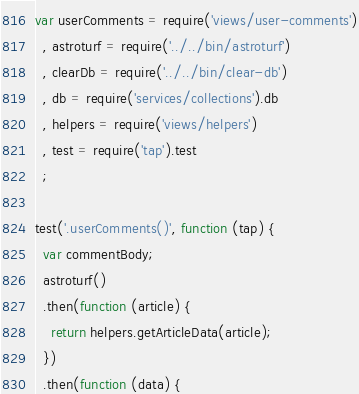Convert code to text. <code><loc_0><loc_0><loc_500><loc_500><_JavaScript_>var userComments = require('views/user-comments')
  , astroturf = require('../../bin/astroturf')
  , clearDb = require('../../bin/clear-db')
  , db = require('services/collections').db
  , helpers = require('views/helpers')
  , test = require('tap').test
  ;

test('.userComments()', function (tap) {
  var commentBody;
  astroturf()
  .then(function (article) {
    return helpers.getArticleData(article);
  })
  .then(function (data) {</code> 